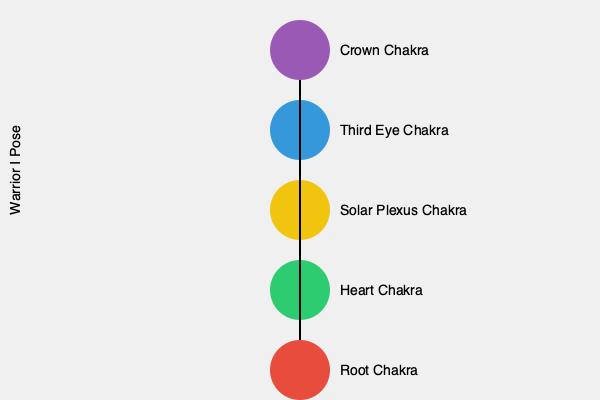Which yoga pose is most closely associated with activating and aligning the Solar Plexus Chakra, and how does it contribute to energy healing in a Reiki session? To answer this question, let's break down the relationship between yoga poses and chakras, specifically focusing on the Solar Plexus Chakra:

1. The Solar Plexus Chakra (Manipura) is located in the upper abdomen, just below the rib cage. It's associated with personal power, confidence, and willpower.

2. Yoga poses that engage the core muscles and stimulate the abdominal area are most effective in activating the Solar Plexus Chakra.

3. The Warrior I Pose (Virabhadrasana I) is particularly effective for this chakra because:
   a. It strengthens the core muscles
   b. It opens the chest and stimulates the upper abdomen
   c. It promotes a sense of strength and confidence

4. In a Reiki session incorporating yoga:
   a. The practitioner may guide the client into Warrior I Pose
   b. This pose helps to open and balance the Solar Plexus Chakra
   c. The practitioner can then focus Reiki energy on this area, enhancing the healing effect

5. The benefits of combining Warrior I Pose with Reiki for the Solar Plexus Chakra include:
   a. Increased self-esteem and personal power
   b. Improved digestion and metabolism
   c. Enhanced ability to set and achieve goals

6. Other poses that can complement Warrior I for the Solar Plexus Chakra include:
   a. Boat Pose (Navasana)
   b. Plank Pose
   c. Bow Pose (Dhanurasana)

By incorporating Warrior I Pose into a Reiki session, the practitioner can effectively target and balance the Solar Plexus Chakra, promoting overall energetic harmony and well-being.
Answer: Warrior I Pose (Virabhadrasana I) 